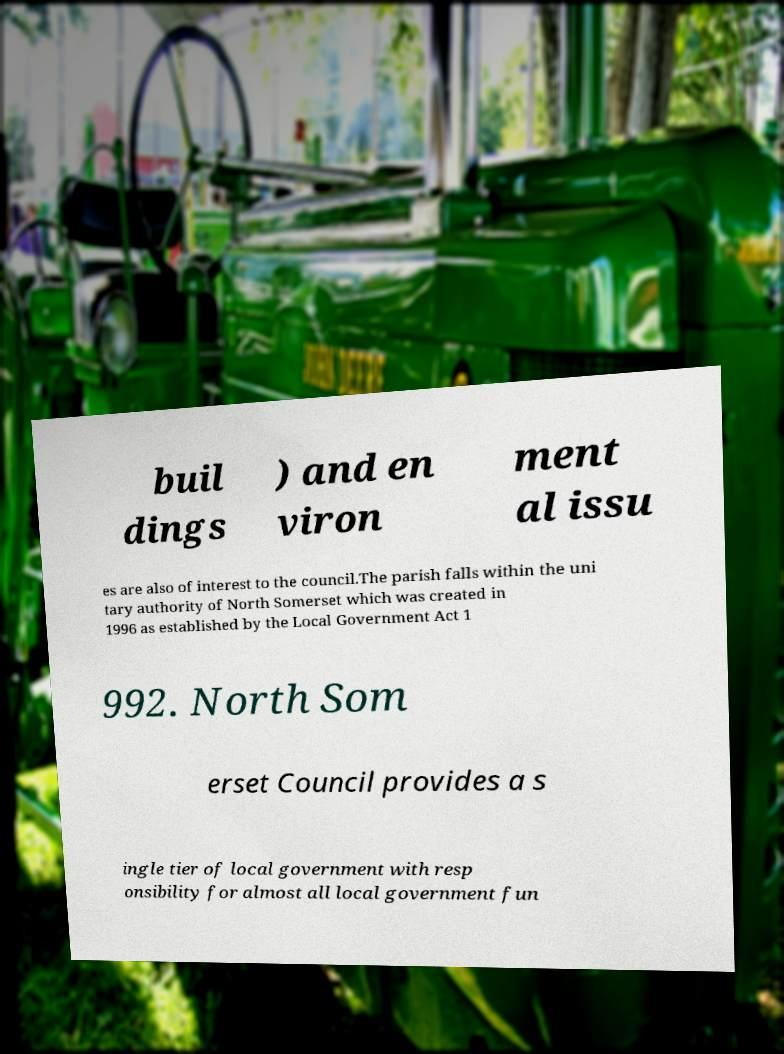There's text embedded in this image that I need extracted. Can you transcribe it verbatim? buil dings ) and en viron ment al issu es are also of interest to the council.The parish falls within the uni tary authority of North Somerset which was created in 1996 as established by the Local Government Act 1 992. North Som erset Council provides a s ingle tier of local government with resp onsibility for almost all local government fun 